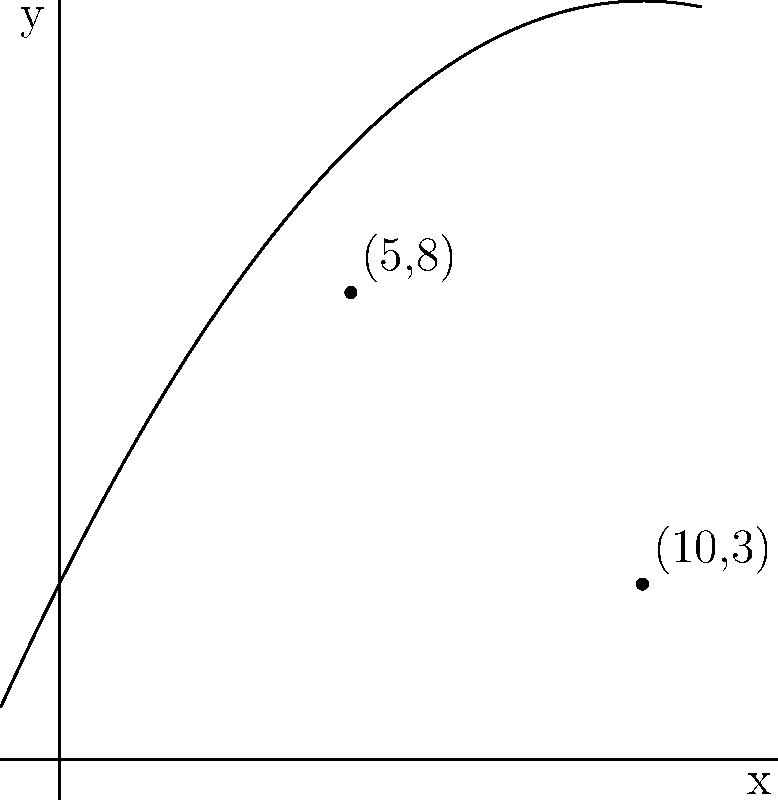As a tennis coach, you're analyzing the trajectory of a serve. The path of the ball is represented by the parabola shown in the coordinate plane above. If the highest point of the trajectory is at (5,8), and the ball lands at (10,3), what is the equation of the parabola? Let's approach this step-by-step:

1) The general form of a parabola is $y = ax^2 + bx + c$.

2) We know three points on this parabola:
   (0,3) - the y-intercept (where the parabola crosses the y-axis)
   (5,8) - the vertex (highest point)
   (10,3) - where the ball lands

3) For a parabola with vertex (h,k), we can use the form:
   $y = a(x-h)^2 + k$

4) Here, h=5 and k=8, so our equation is:
   $y = a(x-5)^2 + 8$

5) We can use the point (10,3) to find 'a':
   $3 = a(10-5)^2 + 8$
   $3 = a(5)^2 + 8$
   $3 = 25a + 8$
   $-5 = 25a$
   $a = -0.2$

6) Therefore, our equation is:
   $y = -0.2(x-5)^2 + 8$

7) Expanding this:
   $y = -0.2(x^2 - 10x + 25) + 8$
   $y = -0.2x^2 + 2x - 5 + 8$
   $y = -0.2x^2 + 2x + 3$

This is the equation of the parabola in standard form.
Answer: $y = -0.2x^2 + 2x + 3$ 